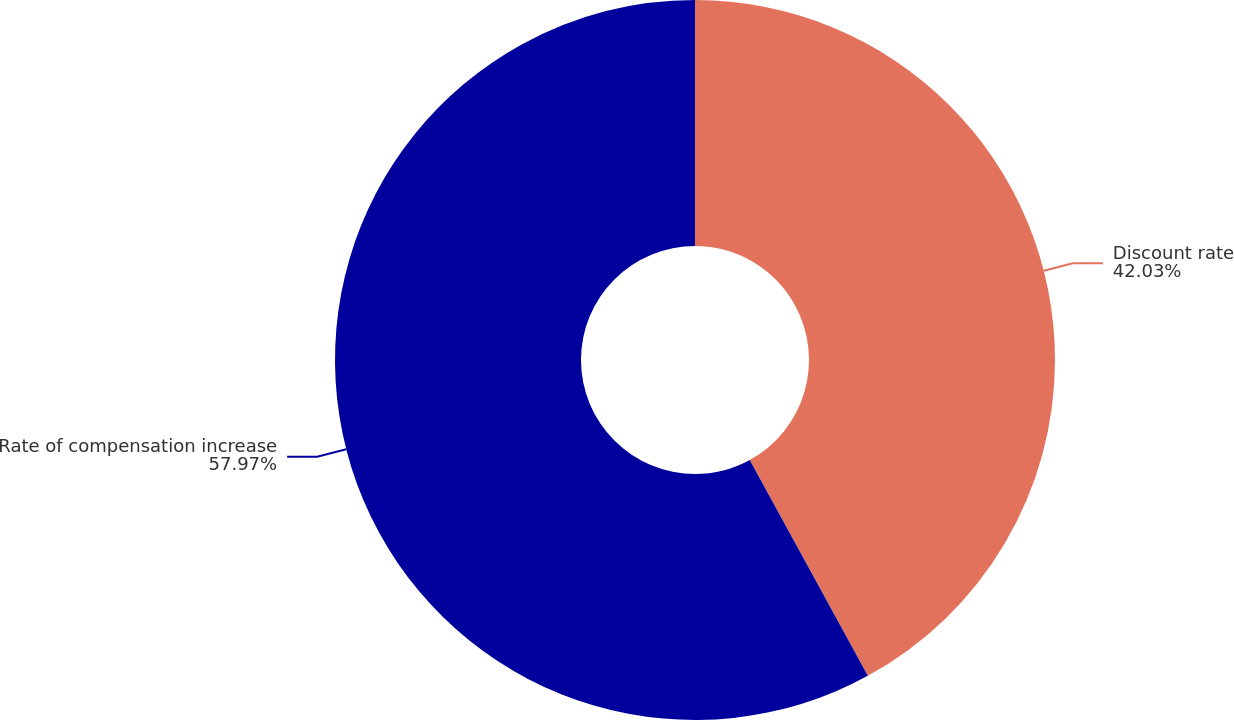Convert chart to OTSL. <chart><loc_0><loc_0><loc_500><loc_500><pie_chart><fcel>Discount rate<fcel>Rate of compensation increase<nl><fcel>42.03%<fcel>57.97%<nl></chart> 